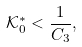<formula> <loc_0><loc_0><loc_500><loc_500>\mathcal { K } _ { 0 } ^ { * } < \frac { 1 } { C _ { 3 } } ,</formula> 